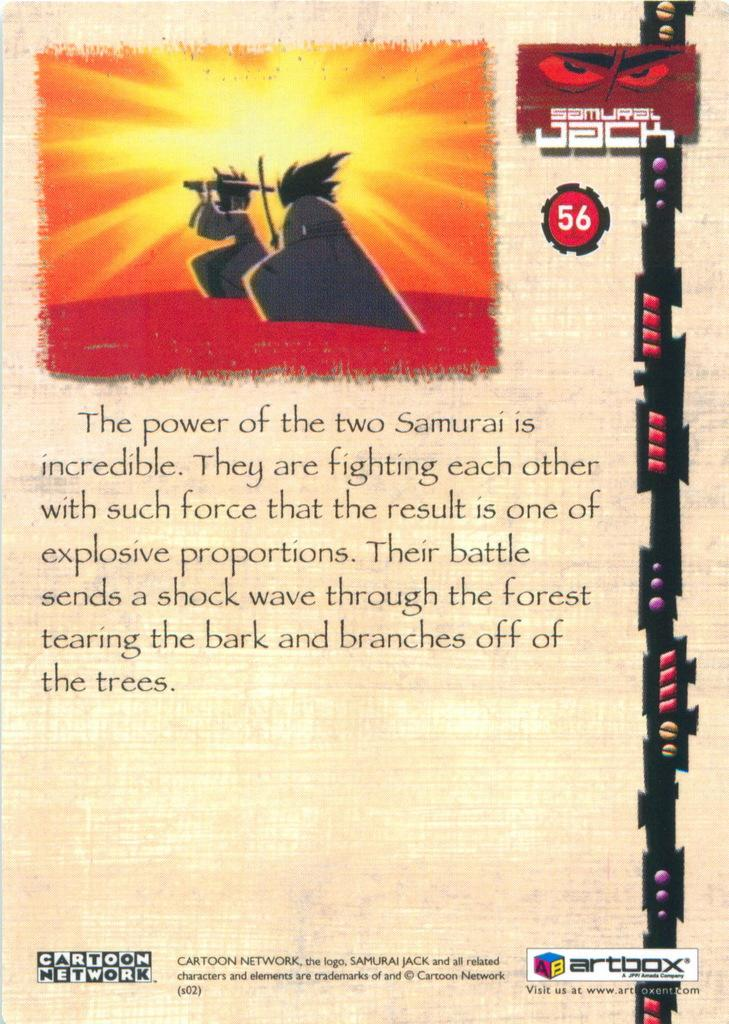<image>
Render a clear and concise summary of the photo. A Samurai Jack playing card with a paragraph of text. 